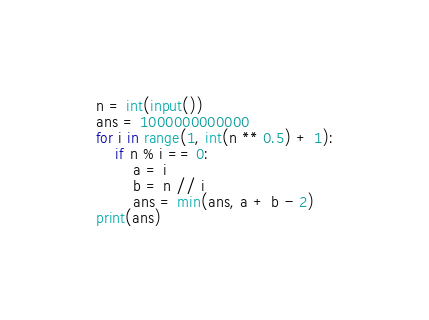<code> <loc_0><loc_0><loc_500><loc_500><_Python_>n = int(input())
ans = 1000000000000
for i in range(1, int(n ** 0.5) + 1):
    if n % i == 0:
        a = i
        b = n // i
        ans = min(ans, a + b - 2)
print(ans)
</code> 